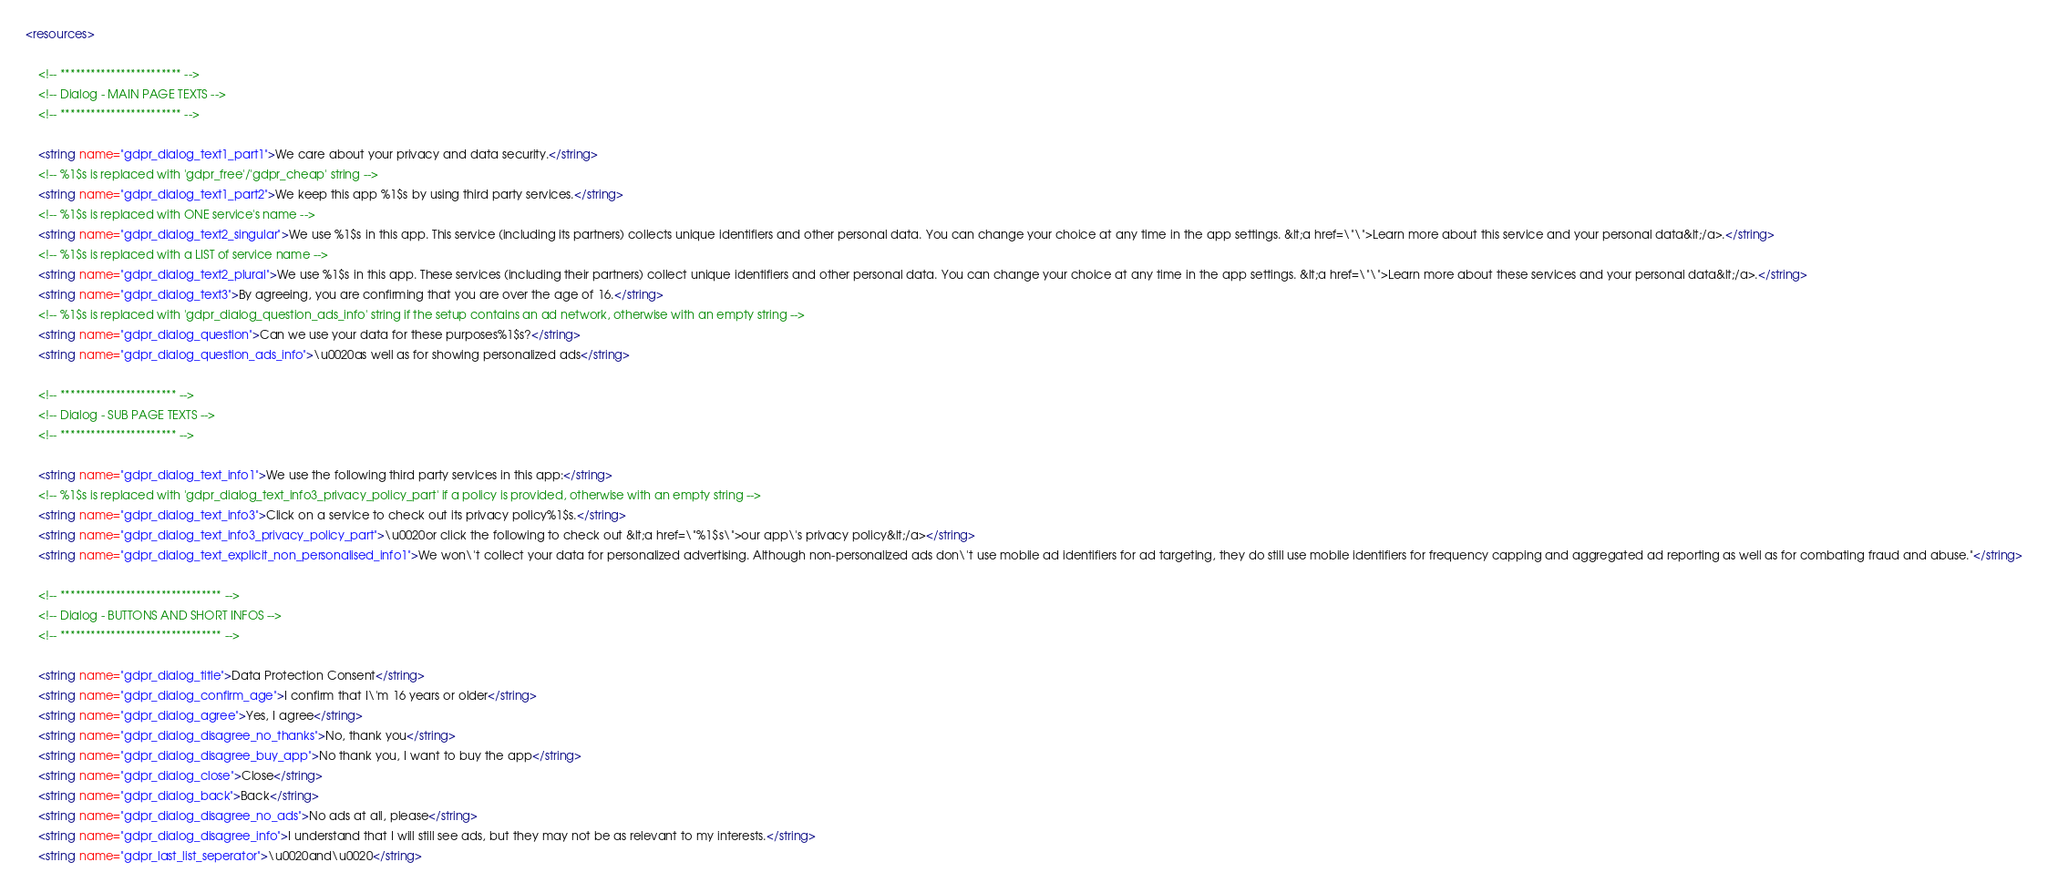<code> <loc_0><loc_0><loc_500><loc_500><_XML_><resources>

    <!-- ************************ -->
    <!-- Dialog - MAIN PAGE TEXTS -->
    <!-- ************************ -->

    <string name="gdpr_dialog_text1_part1">We care about your privacy and data security.</string>
    <!-- %1$s is replaced with 'gdpr_free'/'gdpr_cheap' string -->
    <string name="gdpr_dialog_text1_part2">We keep this app %1$s by using third party services.</string>
    <!-- %1$s is replaced with ONE service's name -->
    <string name="gdpr_dialog_text2_singular">We use %1$s in this app. This service (including its partners) collects unique identifiers and other personal data. You can change your choice at any time in the app settings. &lt;a href=\"\">Learn more about this service and your personal data&lt;/a>.</string>
    <!-- %1$s is replaced with a LIST of service name -->
    <string name="gdpr_dialog_text2_plural">We use %1$s in this app. These services (including their partners) collect unique identifiers and other personal data. You can change your choice at any time in the app settings. &lt;a href=\"\">Learn more about these services and your personal data&lt;/a>.</string>
    <string name="gdpr_dialog_text3">By agreeing, you are confirming that you are over the age of 16.</string>
    <!-- %1$s is replaced with 'gdpr_dialog_question_ads_info' string if the setup contains an ad network, otherwise with an empty string -->
    <string name="gdpr_dialog_question">Can we use your data for these purposes%1$s?</string>
    <string name="gdpr_dialog_question_ads_info">\u0020as well as for showing personalized ads</string>

    <!-- *********************** -->
    <!-- Dialog - SUB PAGE TEXTS -->
    <!-- *********************** -->

    <string name="gdpr_dialog_text_info1">We use the following third party services in this app:</string>
    <!-- %1$s is replaced with 'gdpr_dialog_text_info3_privacy_policy_part' if a policy is provided, otherwise with an empty string -->
    <string name="gdpr_dialog_text_info3">Click on a service to check out its privacy policy%1$s.</string>
    <string name="gdpr_dialog_text_info3_privacy_policy_part">\u0020or click the following to check out &lt;a href=\"%1$s\">our app\'s privacy policy&lt;/a></string>
    <string name="gdpr_dialog_text_explicit_non_personalised_info1">We won\'t collect your data for personalized advertising. Although non-personalized ads don\'t use mobile ad identifiers for ad targeting, they do still use mobile identifiers for frequency capping and aggregated ad reporting as well as for combating fraud and abuse."</string>

    <!-- ******************************** -->
    <!-- Dialog - BUTTONS AND SHORT INFOS -->
    <!-- ******************************** -->

    <string name="gdpr_dialog_title">Data Protection Consent</string>
    <string name="gdpr_dialog_confirm_age">I confirm that I\'m 16 years or older</string>
    <string name="gdpr_dialog_agree">Yes, I agree</string>
    <string name="gdpr_dialog_disagree_no_thanks">No, thank you</string>
    <string name="gdpr_dialog_disagree_buy_app">No thank you, I want to buy the app</string>
    <string name="gdpr_dialog_close">Close</string>
    <string name="gdpr_dialog_back">Back</string>
    <string name="gdpr_dialog_disagree_no_ads">No ads at all, please</string>
    <string name="gdpr_dialog_disagree_info">I understand that I will still see ads, but they may not be as relevant to my interests.</string>
    <string name="gdpr_last_list_seperator">\u0020and\u0020</string></code> 